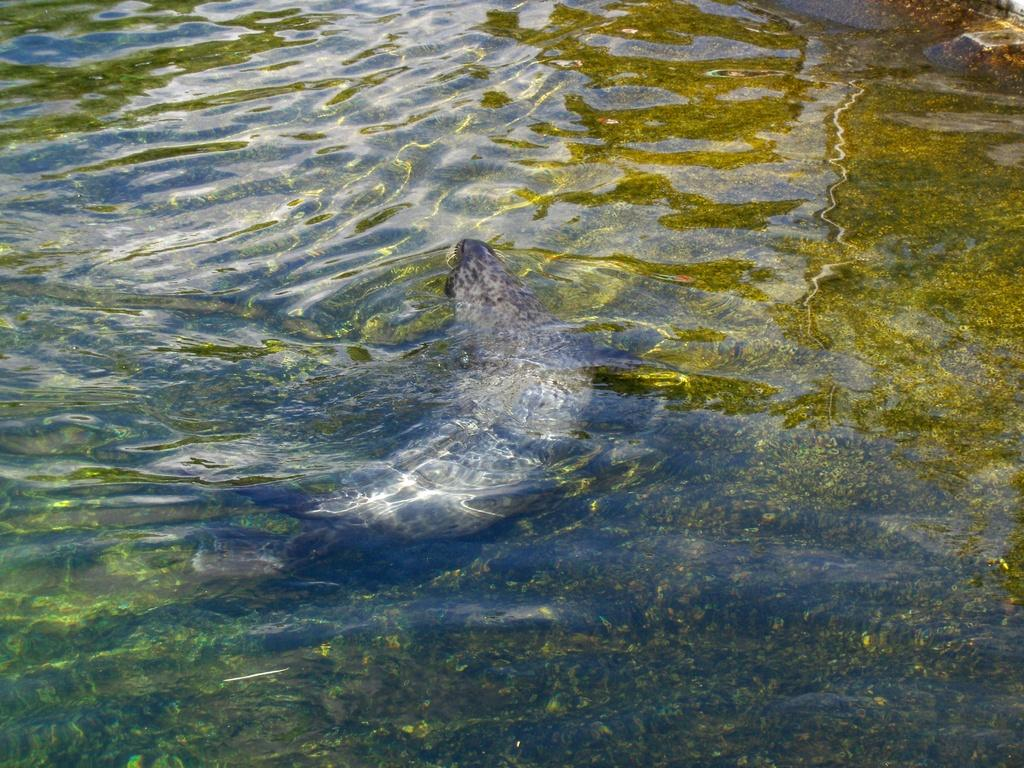What is the primary element visible in the image? There is water in the image. Is there any living creature present in the water? Yes, there is an animal in the water. What type of list can be seen in the image? There is no list present in the image; it features water and an animal in the water. 